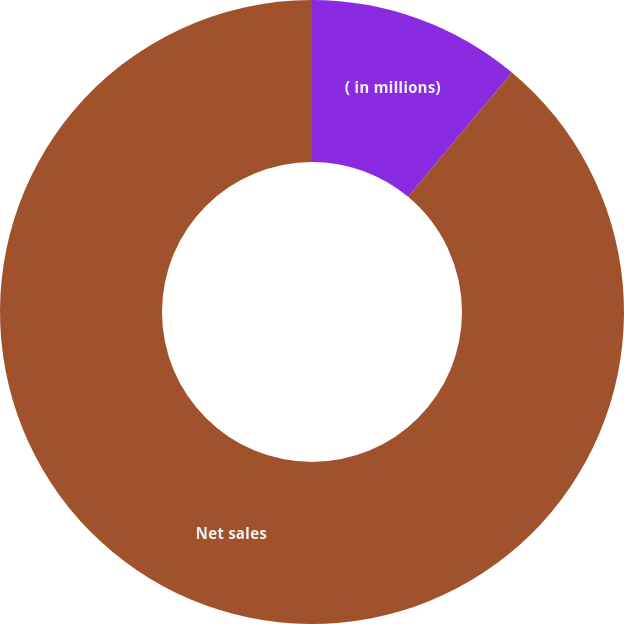Convert chart to OTSL. <chart><loc_0><loc_0><loc_500><loc_500><pie_chart><fcel>( in millions)<fcel>Net sales<nl><fcel>11.07%<fcel>88.93%<nl></chart> 